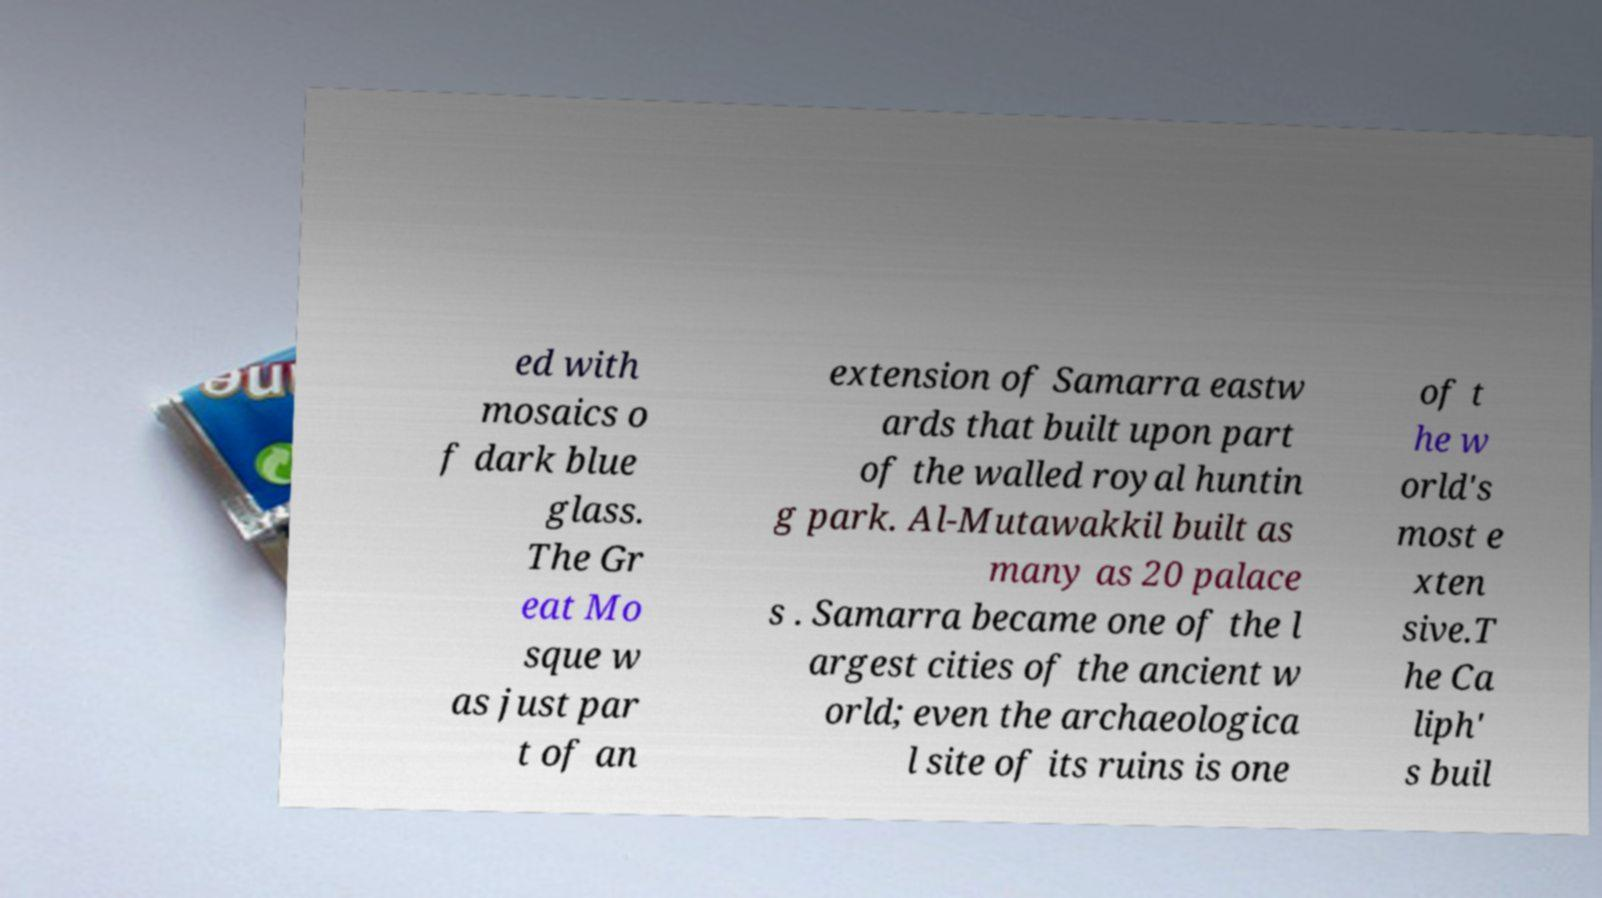Please read and relay the text visible in this image. What does it say? ed with mosaics o f dark blue glass. The Gr eat Mo sque w as just par t of an extension of Samarra eastw ards that built upon part of the walled royal huntin g park. Al-Mutawakkil built as many as 20 palace s . Samarra became one of the l argest cities of the ancient w orld; even the archaeologica l site of its ruins is one of t he w orld's most e xten sive.T he Ca liph' s buil 